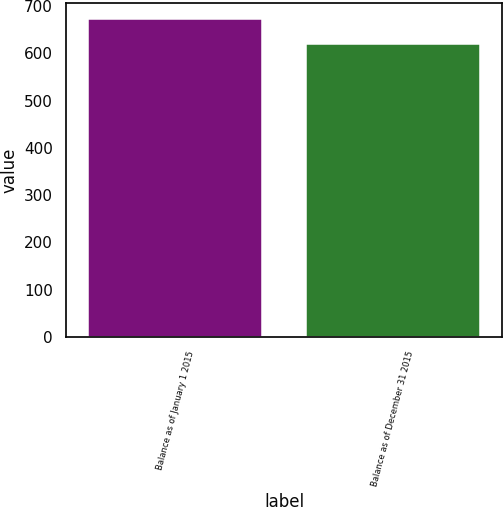Convert chart. <chart><loc_0><loc_0><loc_500><loc_500><bar_chart><fcel>Balance as of January 1 2015<fcel>Balance as of December 31 2015<nl><fcel>673<fcel>620<nl></chart> 